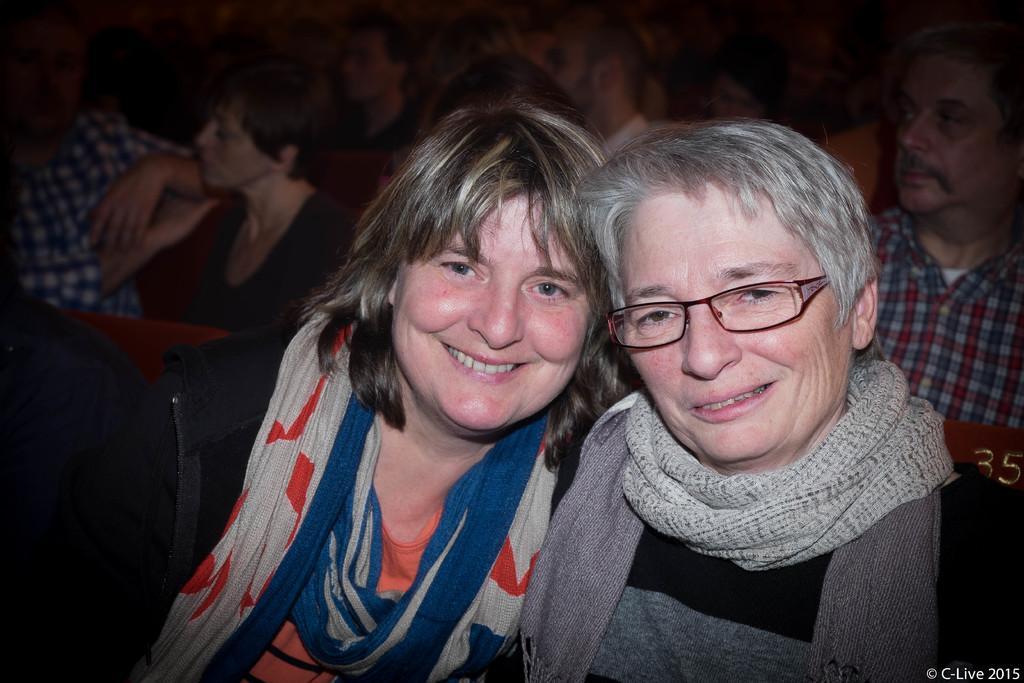How would you summarize this image in a sentence or two? In this image we can see group of persons and seats. In the foreground we can see a person smiling. In the bottom right we can see some text. 